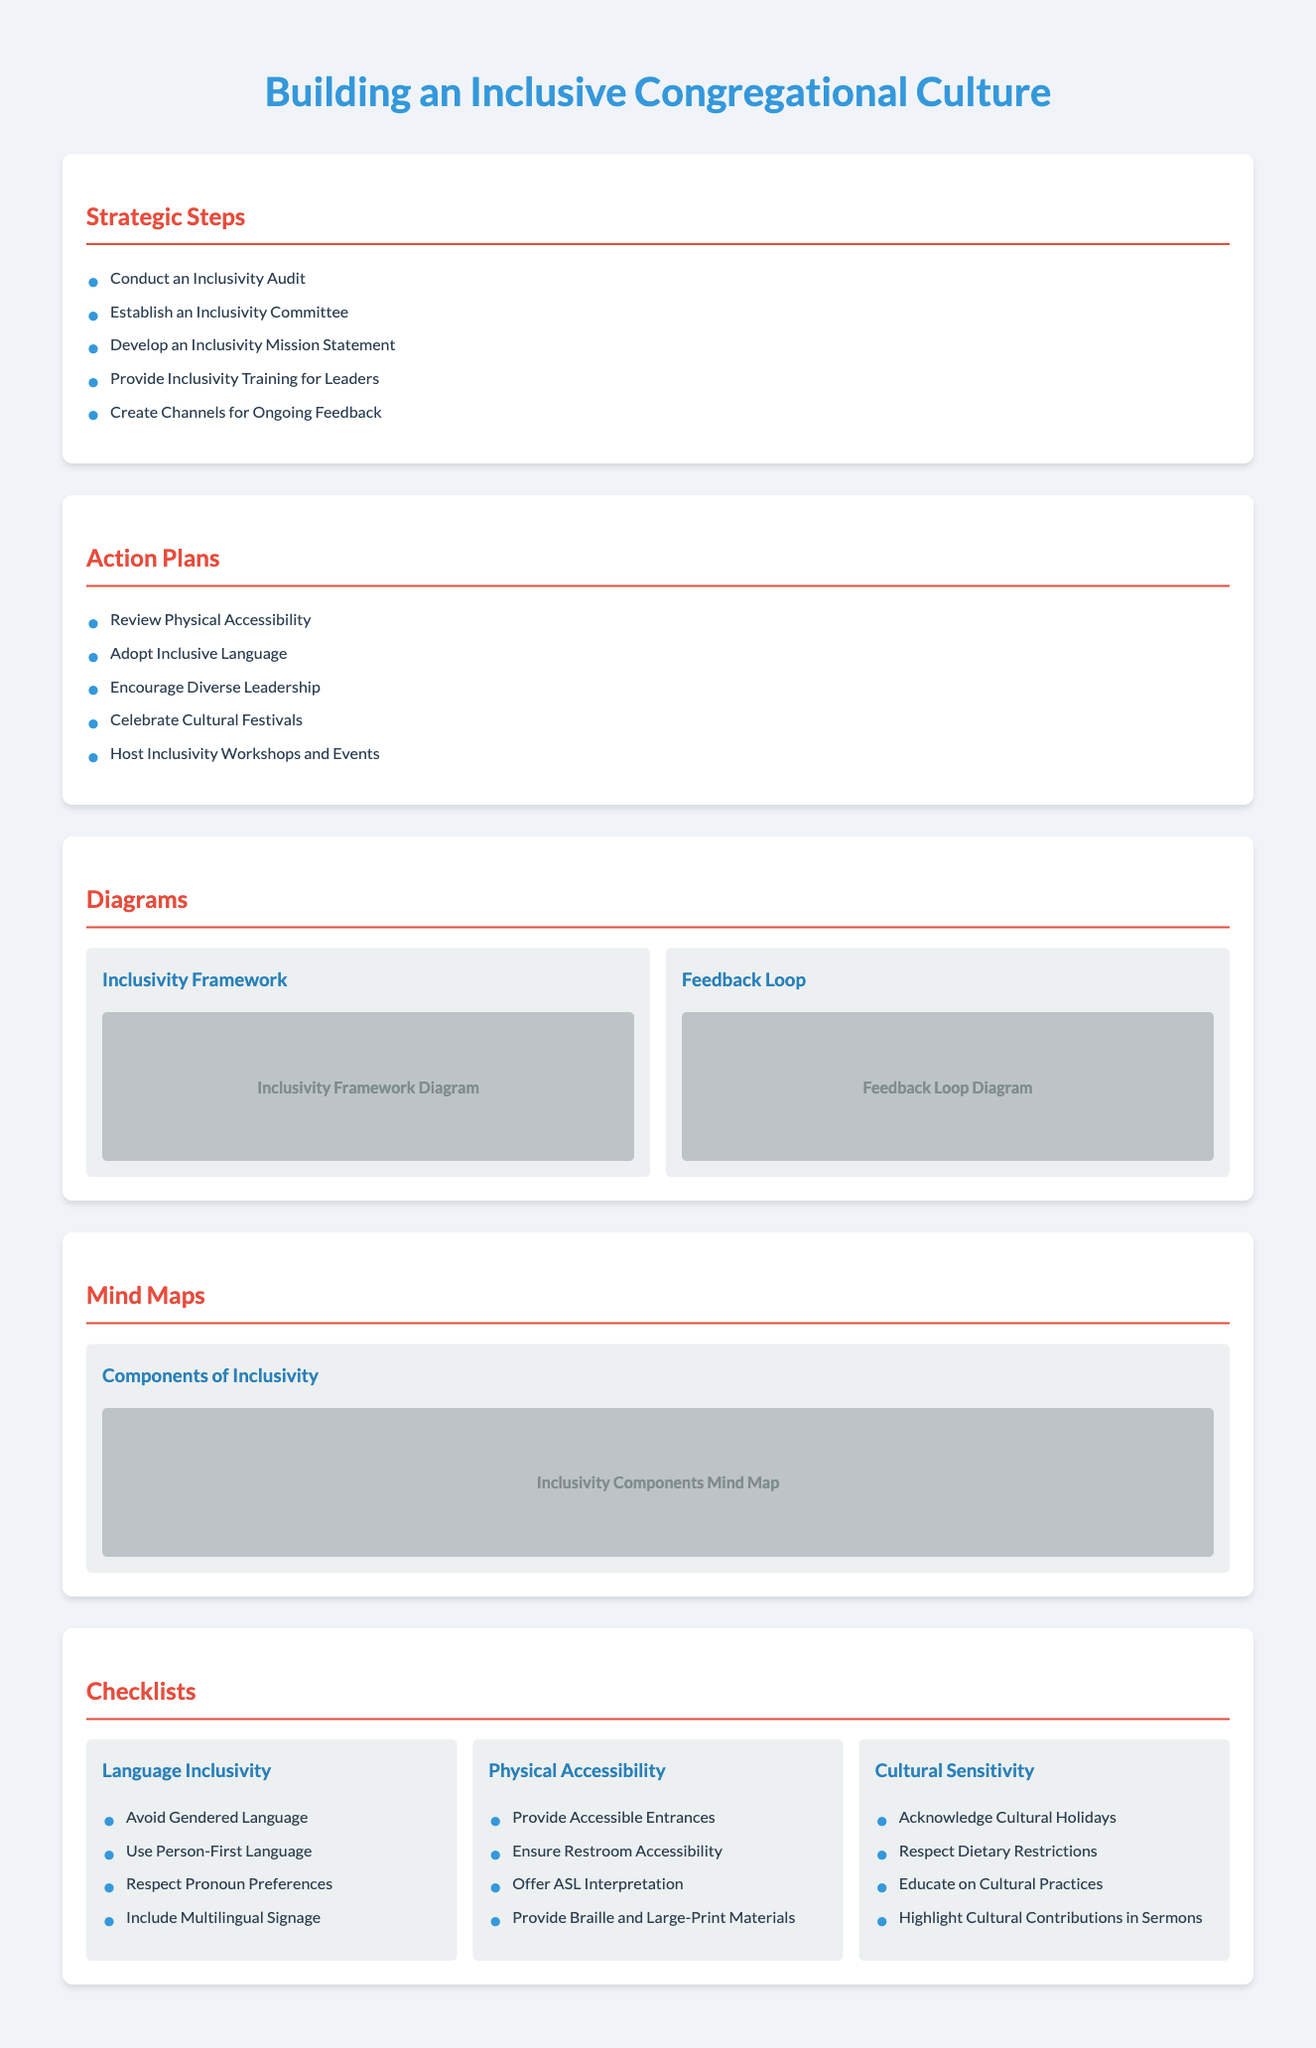What are the strategic steps for building an inclusive culture? The strategic steps are listed in the document under "Strategic Steps," which outlines five specific points.
Answer: Conduct an Inclusivity Audit, Establish an Inclusivity Committee, Develop an Inclusivity Mission Statement, Provide Inclusivity Training for Leaders, Create Channels for Ongoing Feedback How many checklists are provided in the document? The document lists three distinct checklists under the "Checklists" section.
Answer: Three What should be avoided in language inclusivity? The checklist under "Language Inclusivity" specifically mentions one practice to avoid.
Answer: Gendered Language What is one action plan related to physical accessibility? The action plans include several points, one of which addresses physical accessibility directly.
Answer: Review Physical Accessibility What is highlighted in the "Cultural Sensitivity" checklist? The checklist includes specific items related to cultural topics in the church environment.
Answer: Acknowledge Cultural Holidays Which diagram represents the feedback process? The diagrams section contains multiple types of diagrams, one specifically labeled for feedback.
Answer: Feedback Loop Diagram How many components are discussed in the "Components of Inclusivity" mind map? The document refers to a specific diagram that outlines various components of inclusivity.
Answer: Inclusivity Components Mind Map What color is used for headings in the document? The design style of the document indicates a particular color for headings and section titles.
Answer: Red What committee is established for fostering inclusivity? The document specifies the formation of a particular group focused on inclusivity efforts.
Answer: Inclusivity Committee 